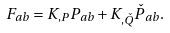<formula> <loc_0><loc_0><loc_500><loc_500>F _ { a b } = K _ { , P } P _ { a b } + K _ { , \check { Q } } \check { P } _ { a b } .</formula> 